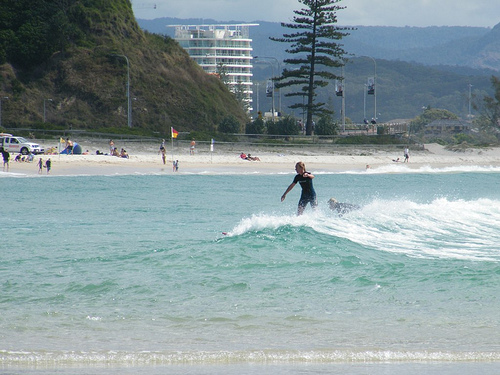Please provide the bounding box coordinate of the region this sentence describes: a person waving their hand. The bounding box coordinates for the person waving their hand are [0.60, 0.42, 0.65, 0.48]. These coordinates highlight the area where the person is waving. Please describe this new bounding box region: [0.25, 0.19, 0.36, 0.30]. The region [0.25, 0.19, 0.36, 0.30] features a group of people lounging on the beach, enjoying the sunny day and serene atmosphere. 